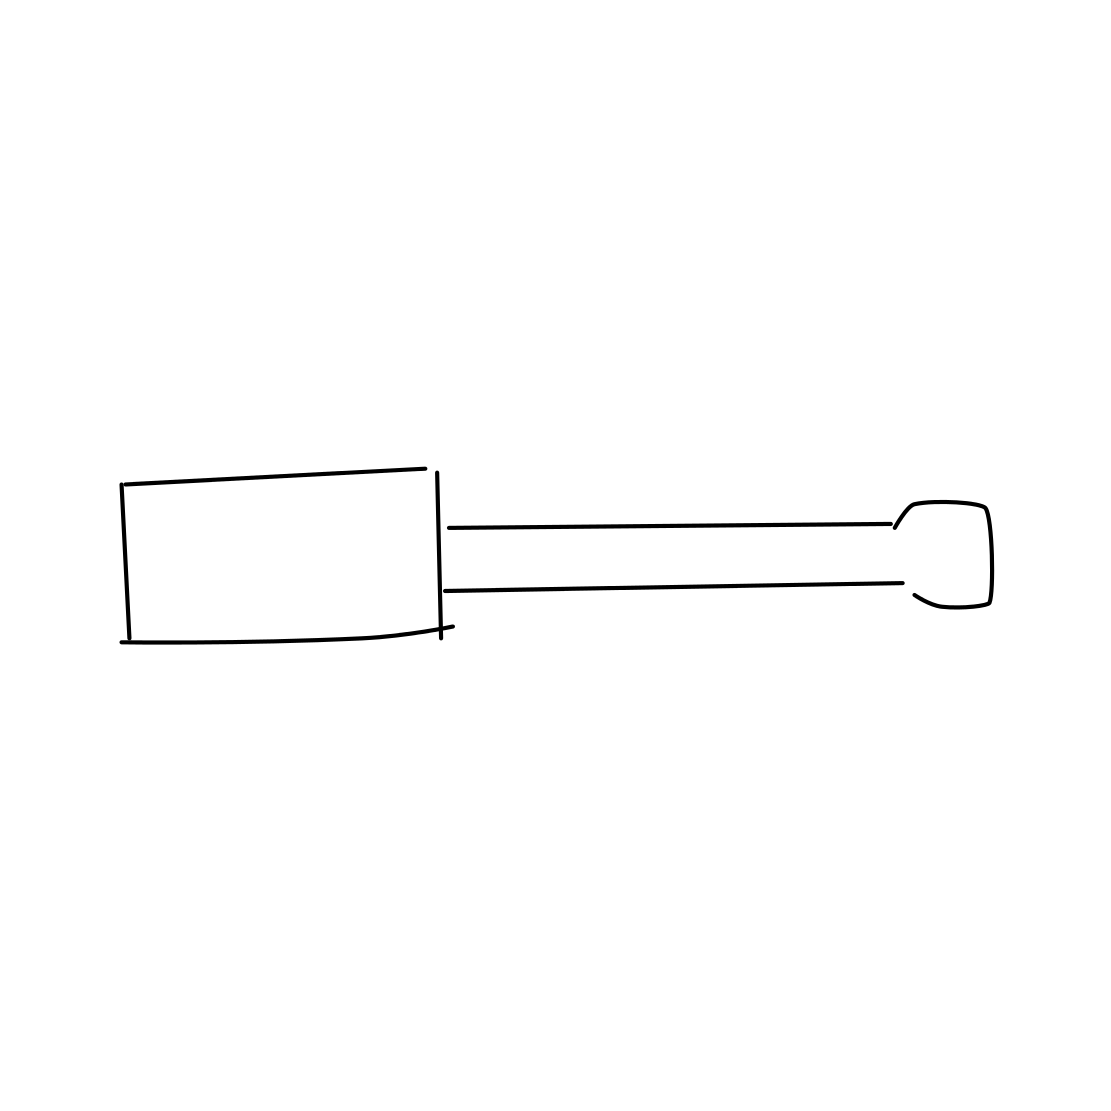In the scene, is a screwdriver in it? Yes 